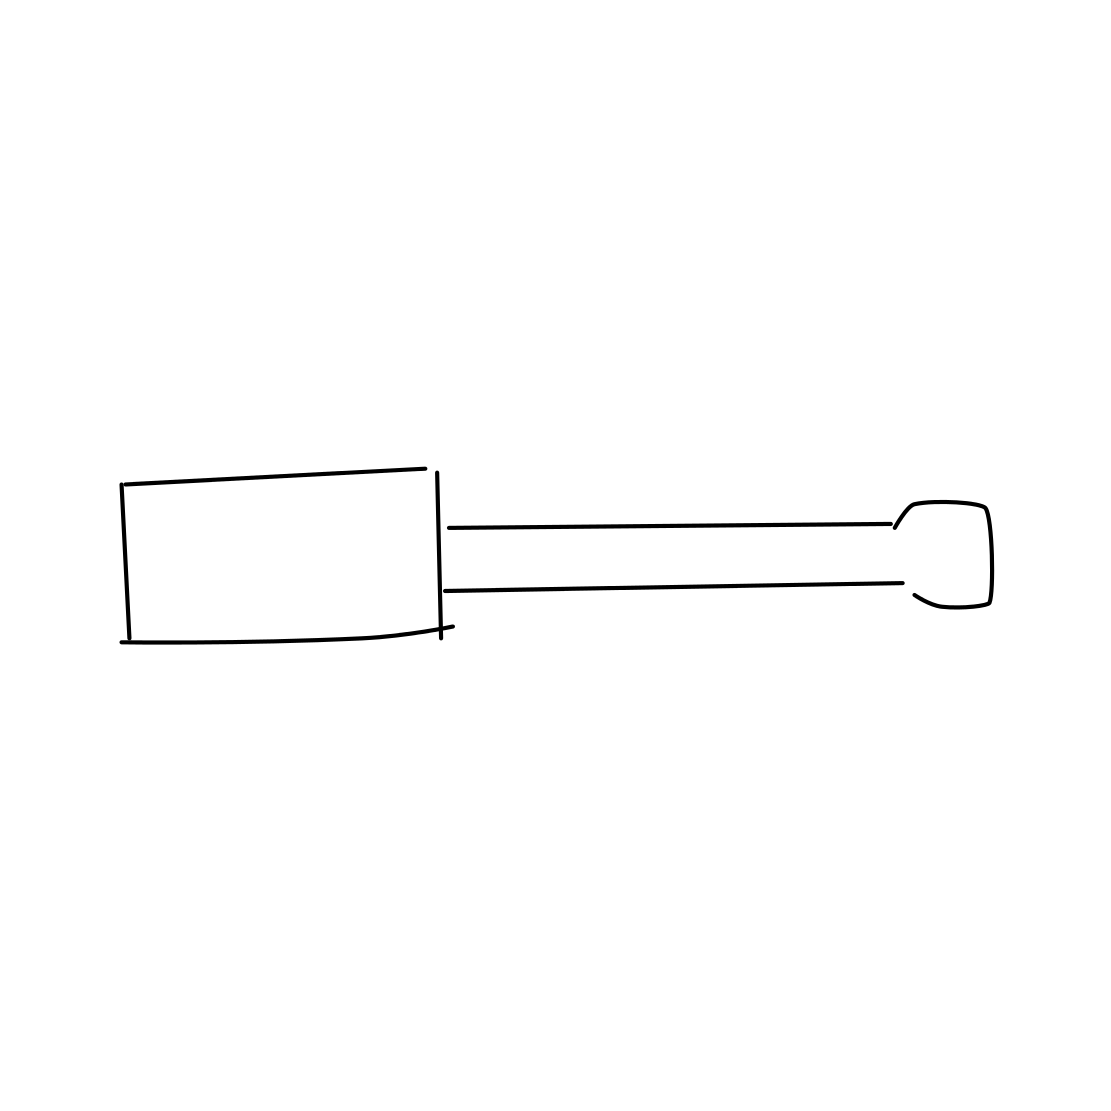In the scene, is a screwdriver in it? Yes 